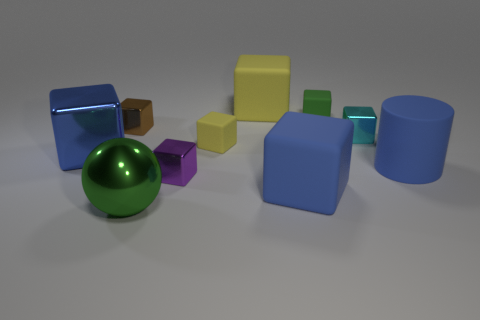The big blue cylinder behind the green thing in front of the big rubber cylinder is made of what material?
Your answer should be compact. Rubber. How many rubber objects are the same color as the large metal sphere?
Make the answer very short. 1. The green cube that is the same material as the big yellow thing is what size?
Provide a short and direct response. Small. What shape is the green thing that is right of the big green ball?
Offer a very short reply. Cube. What is the size of the brown metal thing that is the same shape as the purple shiny thing?
Your answer should be very brief. Small. How many blue objects are to the left of the yellow block behind the tiny cube left of the green metallic object?
Your answer should be very brief. 1. Is the number of shiny objects left of the cyan object the same as the number of small blue rubber objects?
Ensure brevity in your answer.  No. How many cubes are either yellow objects or tiny rubber things?
Your response must be concise. 3. Is the color of the big shiny block the same as the matte cylinder?
Ensure brevity in your answer.  Yes. Are there an equal number of purple blocks behind the big yellow thing and green things that are in front of the tiny green block?
Your answer should be very brief. No. 